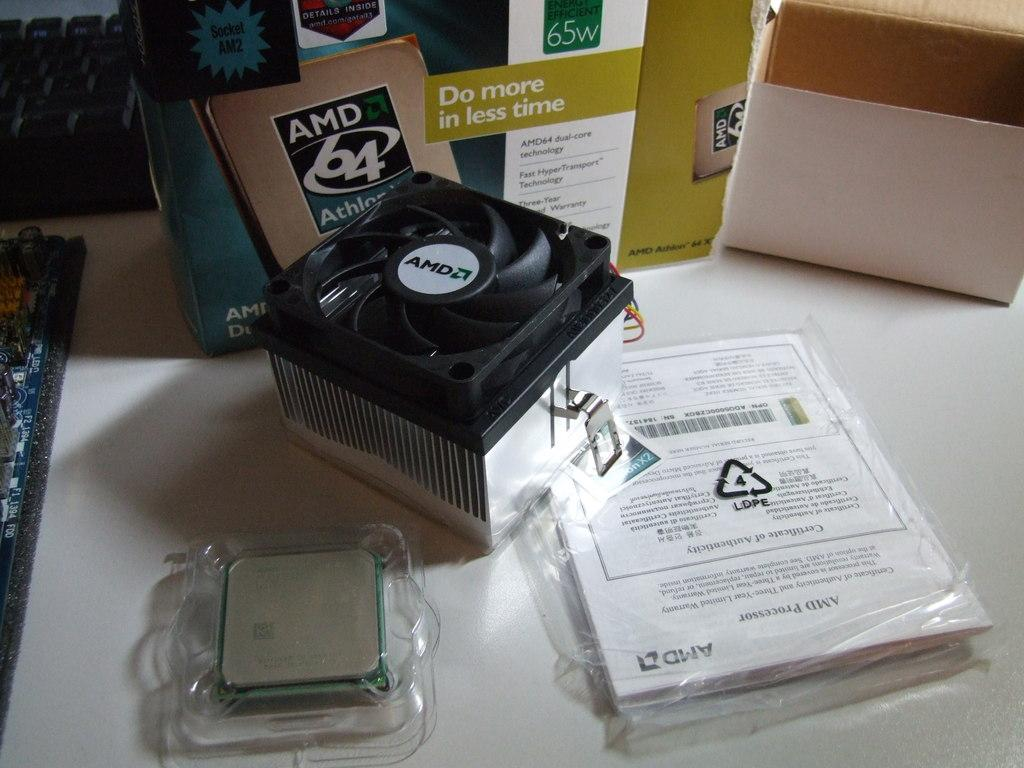<image>
Provide a brief description of the given image. the phrase do more in less time is on a box 